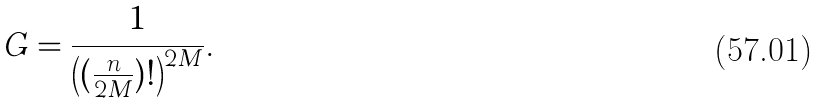<formula> <loc_0><loc_0><loc_500><loc_500>G = \frac { 1 } { \left ( ( \frac { n } { 2 M } ) ! \right ) ^ { 2 M } } .</formula> 